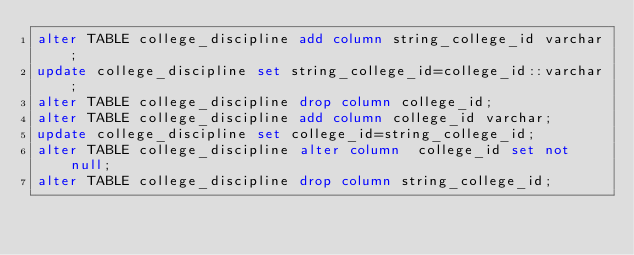Convert code to text. <code><loc_0><loc_0><loc_500><loc_500><_SQL_>alter TABLE college_discipline add column string_college_id varchar;
update college_discipline set string_college_id=college_id::varchar;
alter TABLE college_discipline drop column college_id;
alter TABLE college_discipline add column college_id varchar;
update college_discipline set college_id=string_college_id;
alter TABLE college_discipline alter column  college_id set not null;
alter TABLE college_discipline drop column string_college_id;
</code> 